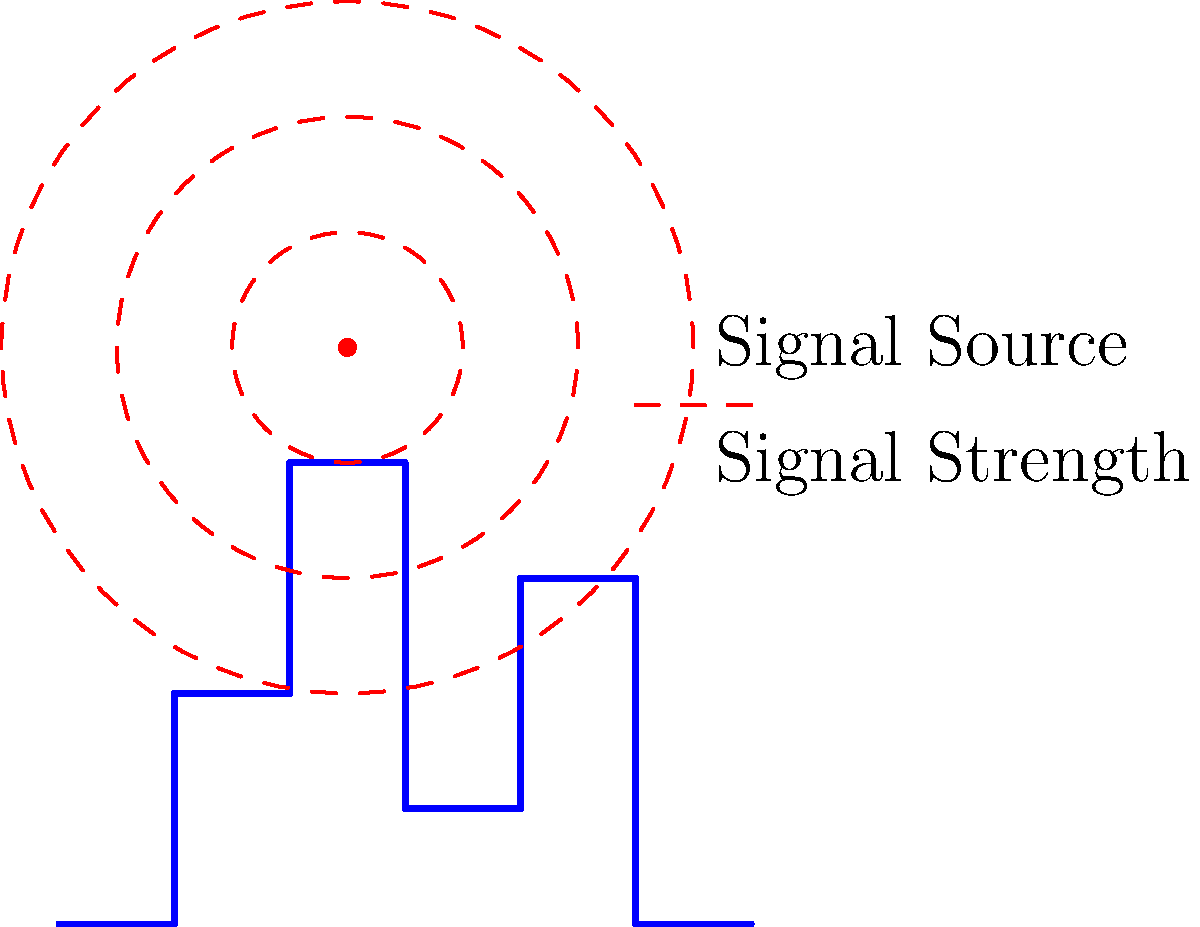In an urban environment with varying building heights, you need to map wireless signal coverage for your IoT devices. Given the signal source location and propagation pattern shown in the diagram, which factor is most critical to consider when predicting signal strength and coverage in this scenario? To accurately predict signal strength and coverage in an urban environment, we need to consider several factors:

1. Line of sight: In urban areas, buildings obstruct direct paths between the signal source and receivers.

2. Multipath propagation: Signals reflect off buildings, creating multiple paths to reach a single point.

3. Diffraction: Signals bend around corners of buildings, potentially reaching areas without direct line of sight.

4. Absorption: Building materials absorb some of the signal energy, reducing strength.

5. Interference: Other wireless sources in urban areas can interfere with the signal.

However, the most critical factor in this scenario is the effect of buildings on signal propagation, specifically:

6. Shadow fading (or shadowing): This occurs when large obstacles, like buildings, block the signal path, creating "shadows" or areas of significantly reduced signal strength.

In the diagram, we can see that the buildings have varying heights and densities. These structures will create complex patterns of shadow fading, which will have the most substantial impact on signal coverage.

While other factors are important, shadow fading due to the urban landscape will be the primary determinant of signal strength variations and coverage gaps in this environment. It directly affects the ability of IoT devices to maintain reliable connections, especially in areas behind tall buildings or in dense clusters of structures.
Answer: Shadow fading 